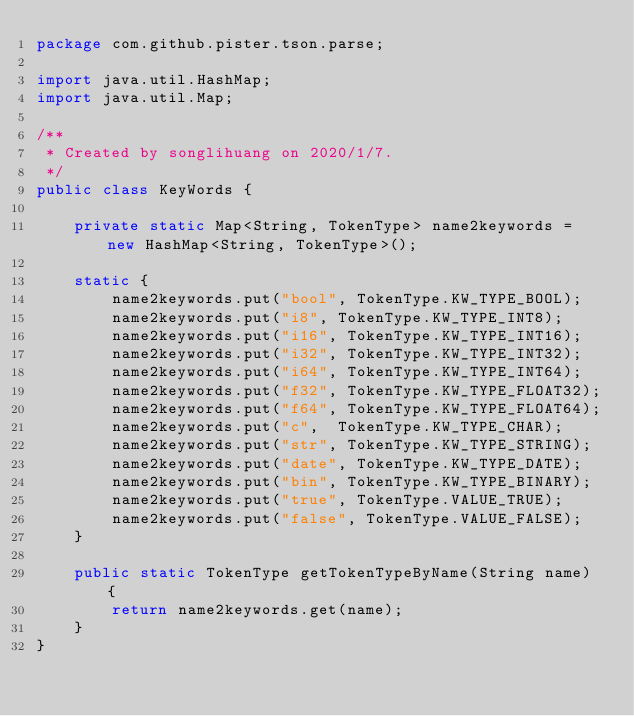Convert code to text. <code><loc_0><loc_0><loc_500><loc_500><_Java_>package com.github.pister.tson.parse;

import java.util.HashMap;
import java.util.Map;

/**
 * Created by songlihuang on 2020/1/7.
 */
public class KeyWords {

    private static Map<String, TokenType> name2keywords = new HashMap<String, TokenType>();

    static {
        name2keywords.put("bool", TokenType.KW_TYPE_BOOL);
        name2keywords.put("i8", TokenType.KW_TYPE_INT8);
        name2keywords.put("i16", TokenType.KW_TYPE_INT16);
        name2keywords.put("i32", TokenType.KW_TYPE_INT32);
        name2keywords.put("i64", TokenType.KW_TYPE_INT64);
        name2keywords.put("f32", TokenType.KW_TYPE_FLOAT32);
        name2keywords.put("f64", TokenType.KW_TYPE_FLOAT64);
        name2keywords.put("c",  TokenType.KW_TYPE_CHAR);
        name2keywords.put("str", TokenType.KW_TYPE_STRING);
        name2keywords.put("date", TokenType.KW_TYPE_DATE);
        name2keywords.put("bin", TokenType.KW_TYPE_BINARY);
        name2keywords.put("true", TokenType.VALUE_TRUE);
        name2keywords.put("false", TokenType.VALUE_FALSE);
    }

    public static TokenType getTokenTypeByName(String name) {
        return name2keywords.get(name);
    }
}
</code> 